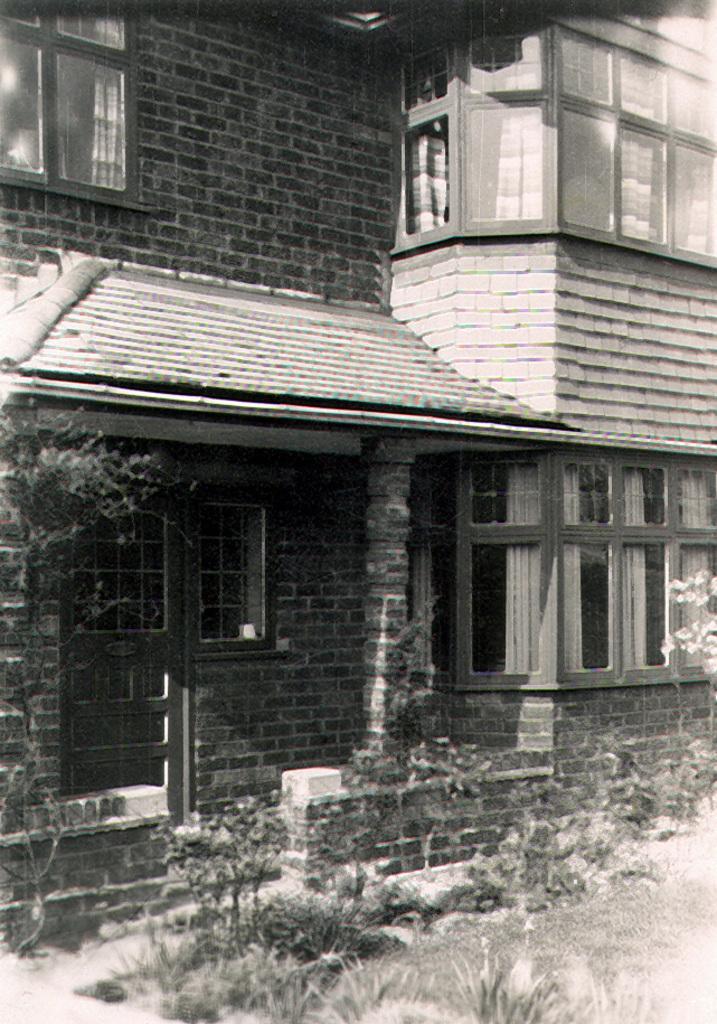Can you describe this image briefly? This is a black and white picture. At the bottom of the picture, we see the grass and the plants. On the left side, we see a tree. In the background, we see a building which is made up of bricks. It has windows. 